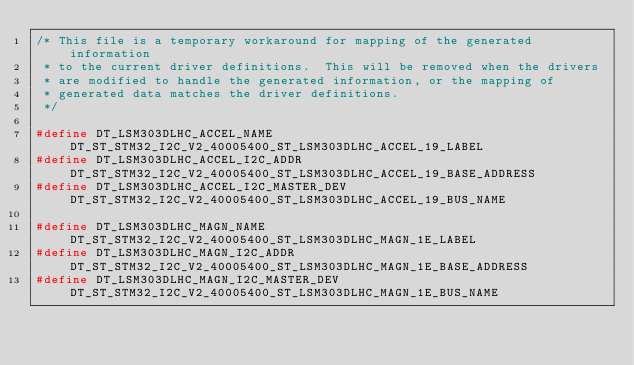Convert code to text. <code><loc_0><loc_0><loc_500><loc_500><_C_>/* This file is a temporary workaround for mapping of the generated information
 * to the current driver definitions.  This will be removed when the drivers
 * are modified to handle the generated information, or the mapping of
 * generated data matches the driver definitions.
 */

#define DT_LSM303DLHC_ACCEL_NAME			DT_ST_STM32_I2C_V2_40005400_ST_LSM303DLHC_ACCEL_19_LABEL
#define DT_LSM303DLHC_ACCEL_I2C_ADDR		DT_ST_STM32_I2C_V2_40005400_ST_LSM303DLHC_ACCEL_19_BASE_ADDRESS
#define DT_LSM303DLHC_ACCEL_I2C_MASTER_DEV		DT_ST_STM32_I2C_V2_40005400_ST_LSM303DLHC_ACCEL_19_BUS_NAME

#define DT_LSM303DLHC_MAGN_NAME			DT_ST_STM32_I2C_V2_40005400_ST_LSM303DLHC_MAGN_1E_LABEL
#define DT_LSM303DLHC_MAGN_I2C_ADDR			DT_ST_STM32_I2C_V2_40005400_ST_LSM303DLHC_MAGN_1E_BASE_ADDRESS
#define DT_LSM303DLHC_MAGN_I2C_MASTER_DEV		DT_ST_STM32_I2C_V2_40005400_ST_LSM303DLHC_MAGN_1E_BUS_NAME
</code> 